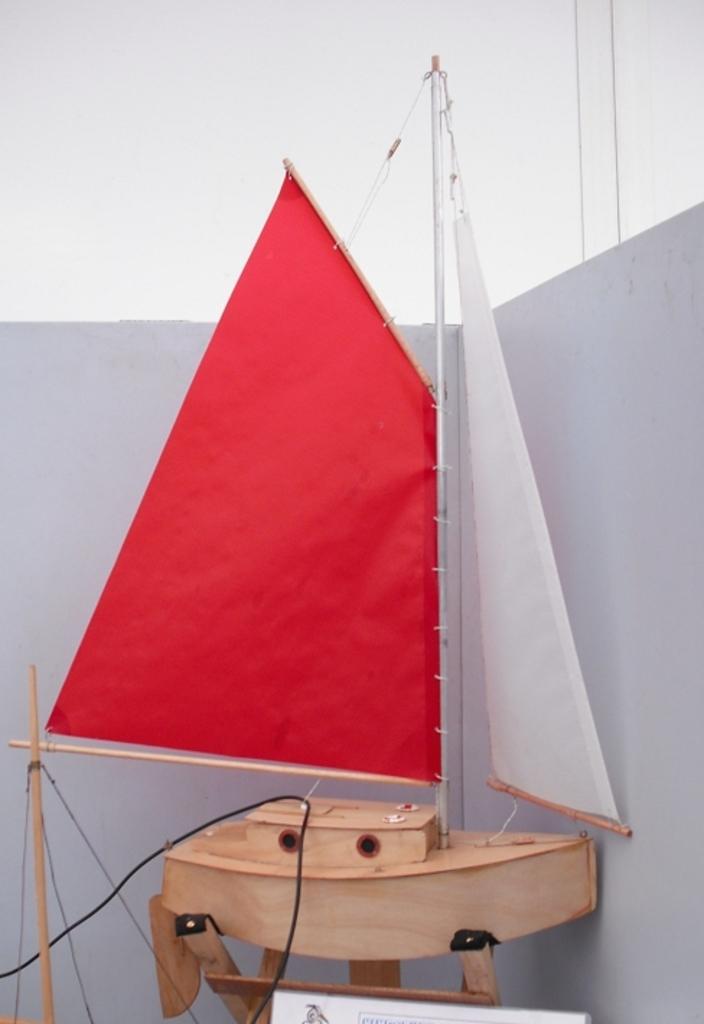How would you summarize this image in a sentence or two? In this image there is a ship toy which is of a wooden material is kept on a stand which is before a wall. Top of image there is sky. 